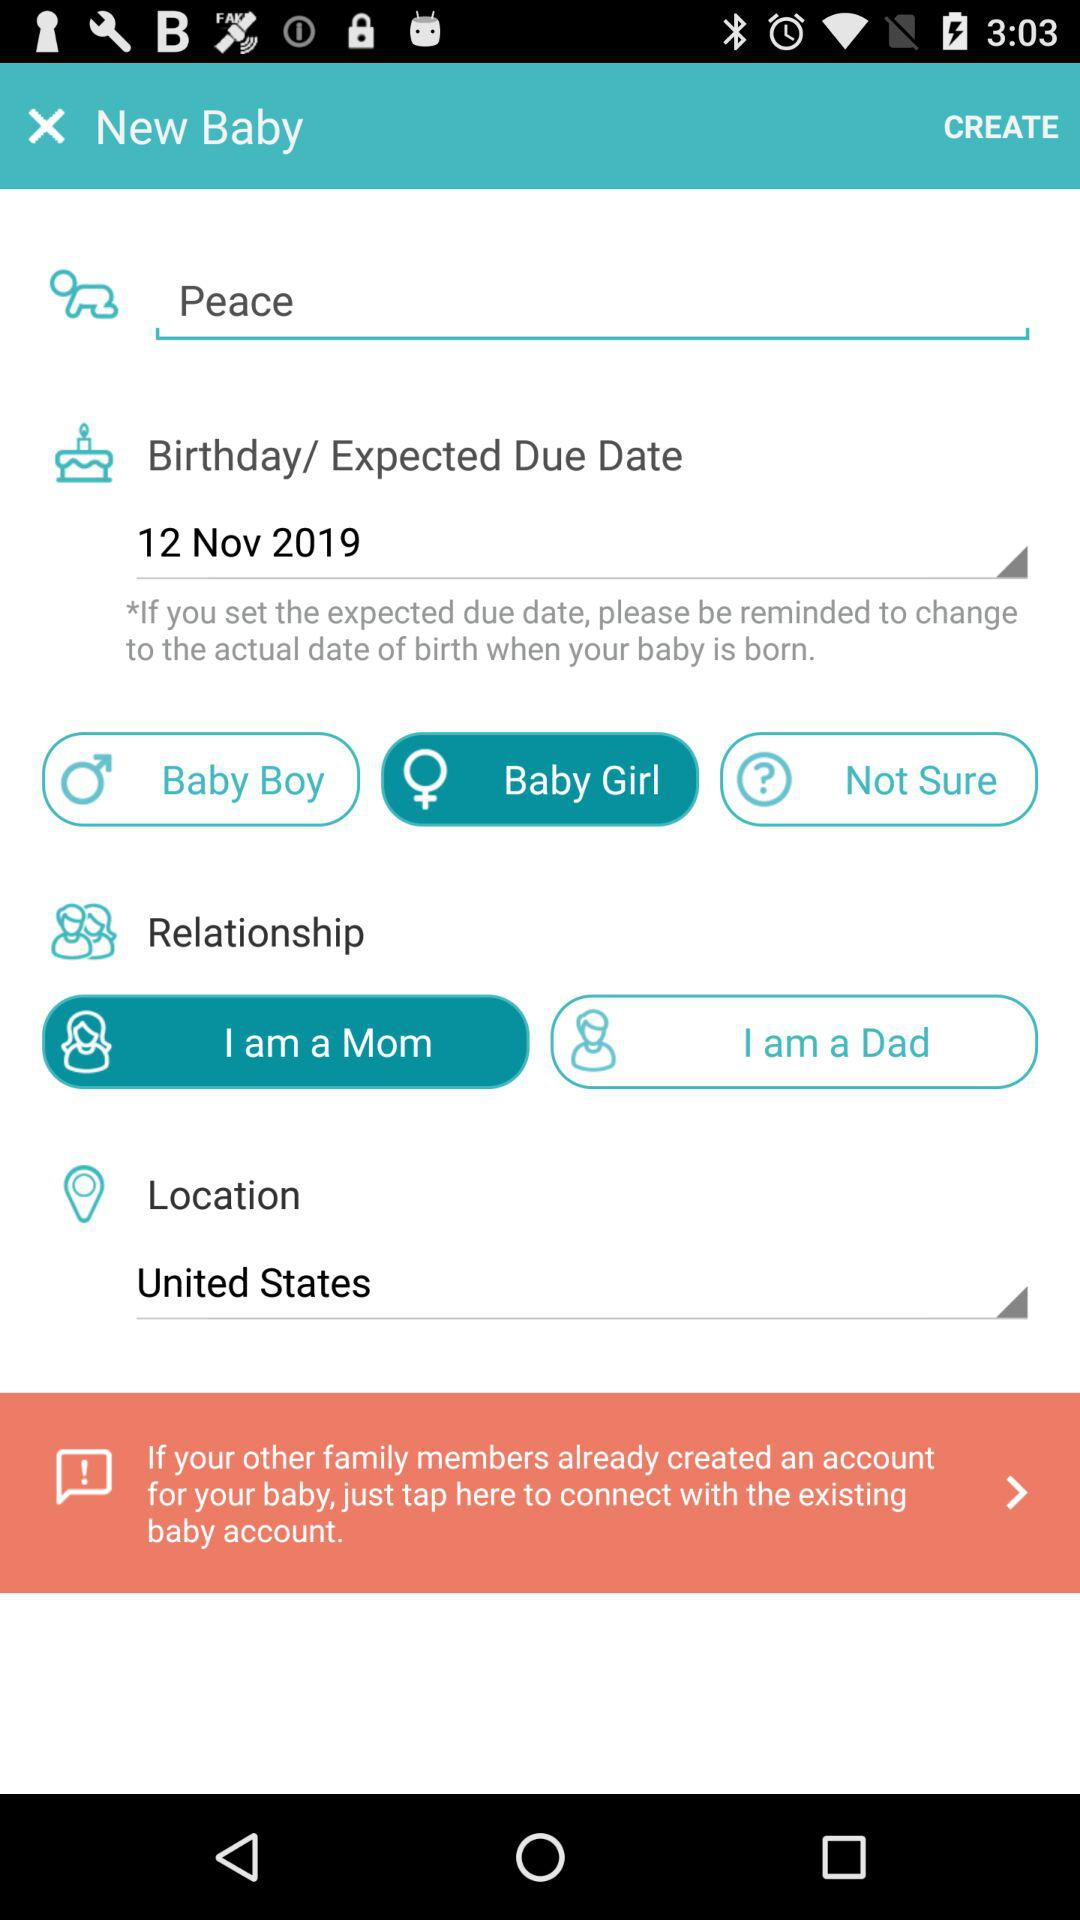What is the relationship with the new baby? The relationship is "I am a Mom". 